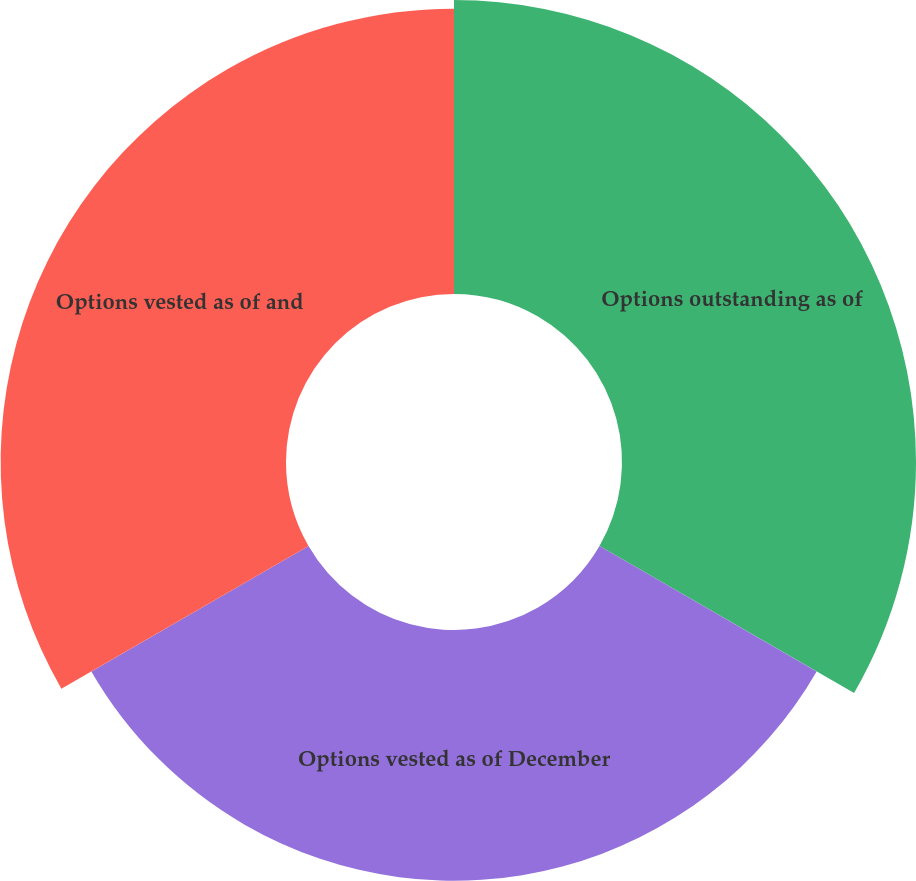Convert chart to OTSL. <chart><loc_0><loc_0><loc_500><loc_500><pie_chart><fcel>Options outstanding as of<fcel>Options vested as of December<fcel>Options vested as of and<nl><fcel>35.42%<fcel>30.21%<fcel>34.38%<nl></chart> 